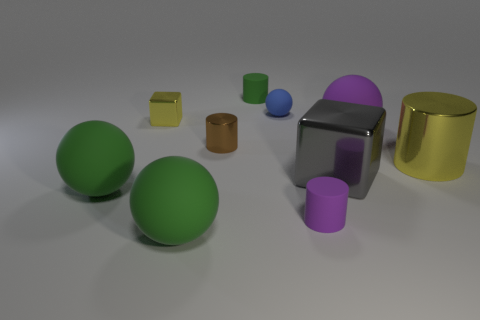What can you infer about the positioning of the objects, does it seem deliberate or random? The positioning of the objects seems to be somewhat deliberate. The objects are spread out across the surface, neither too clustered nor too evenly spaced, which might suggest an attempt to create a balanced composition. The varying sizes and colors of the objects also provide a sense of depth and perspective. 